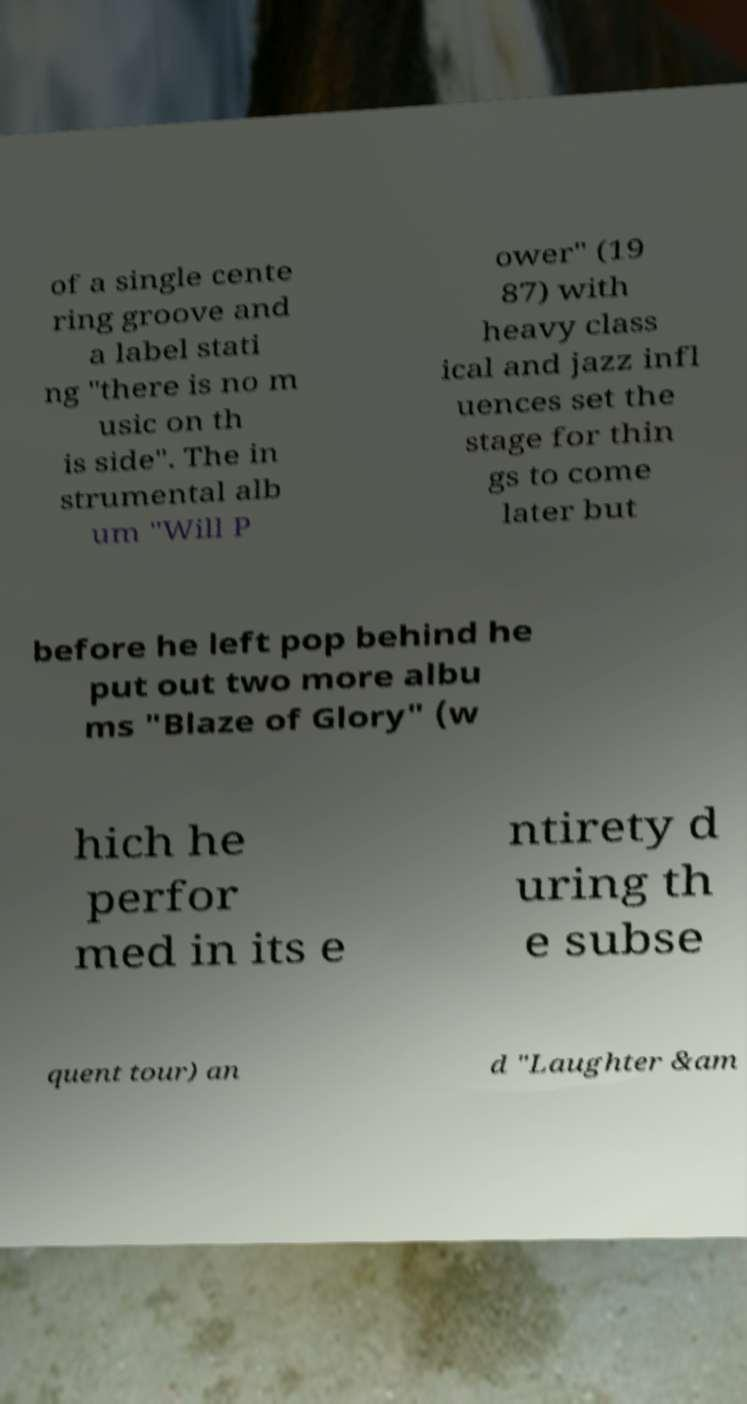What messages or text are displayed in this image? I need them in a readable, typed format. of a single cente ring groove and a label stati ng "there is no m usic on th is side". The in strumental alb um "Will P ower" (19 87) with heavy class ical and jazz infl uences set the stage for thin gs to come later but before he left pop behind he put out two more albu ms "Blaze of Glory" (w hich he perfor med in its e ntirety d uring th e subse quent tour) an d "Laughter &am 